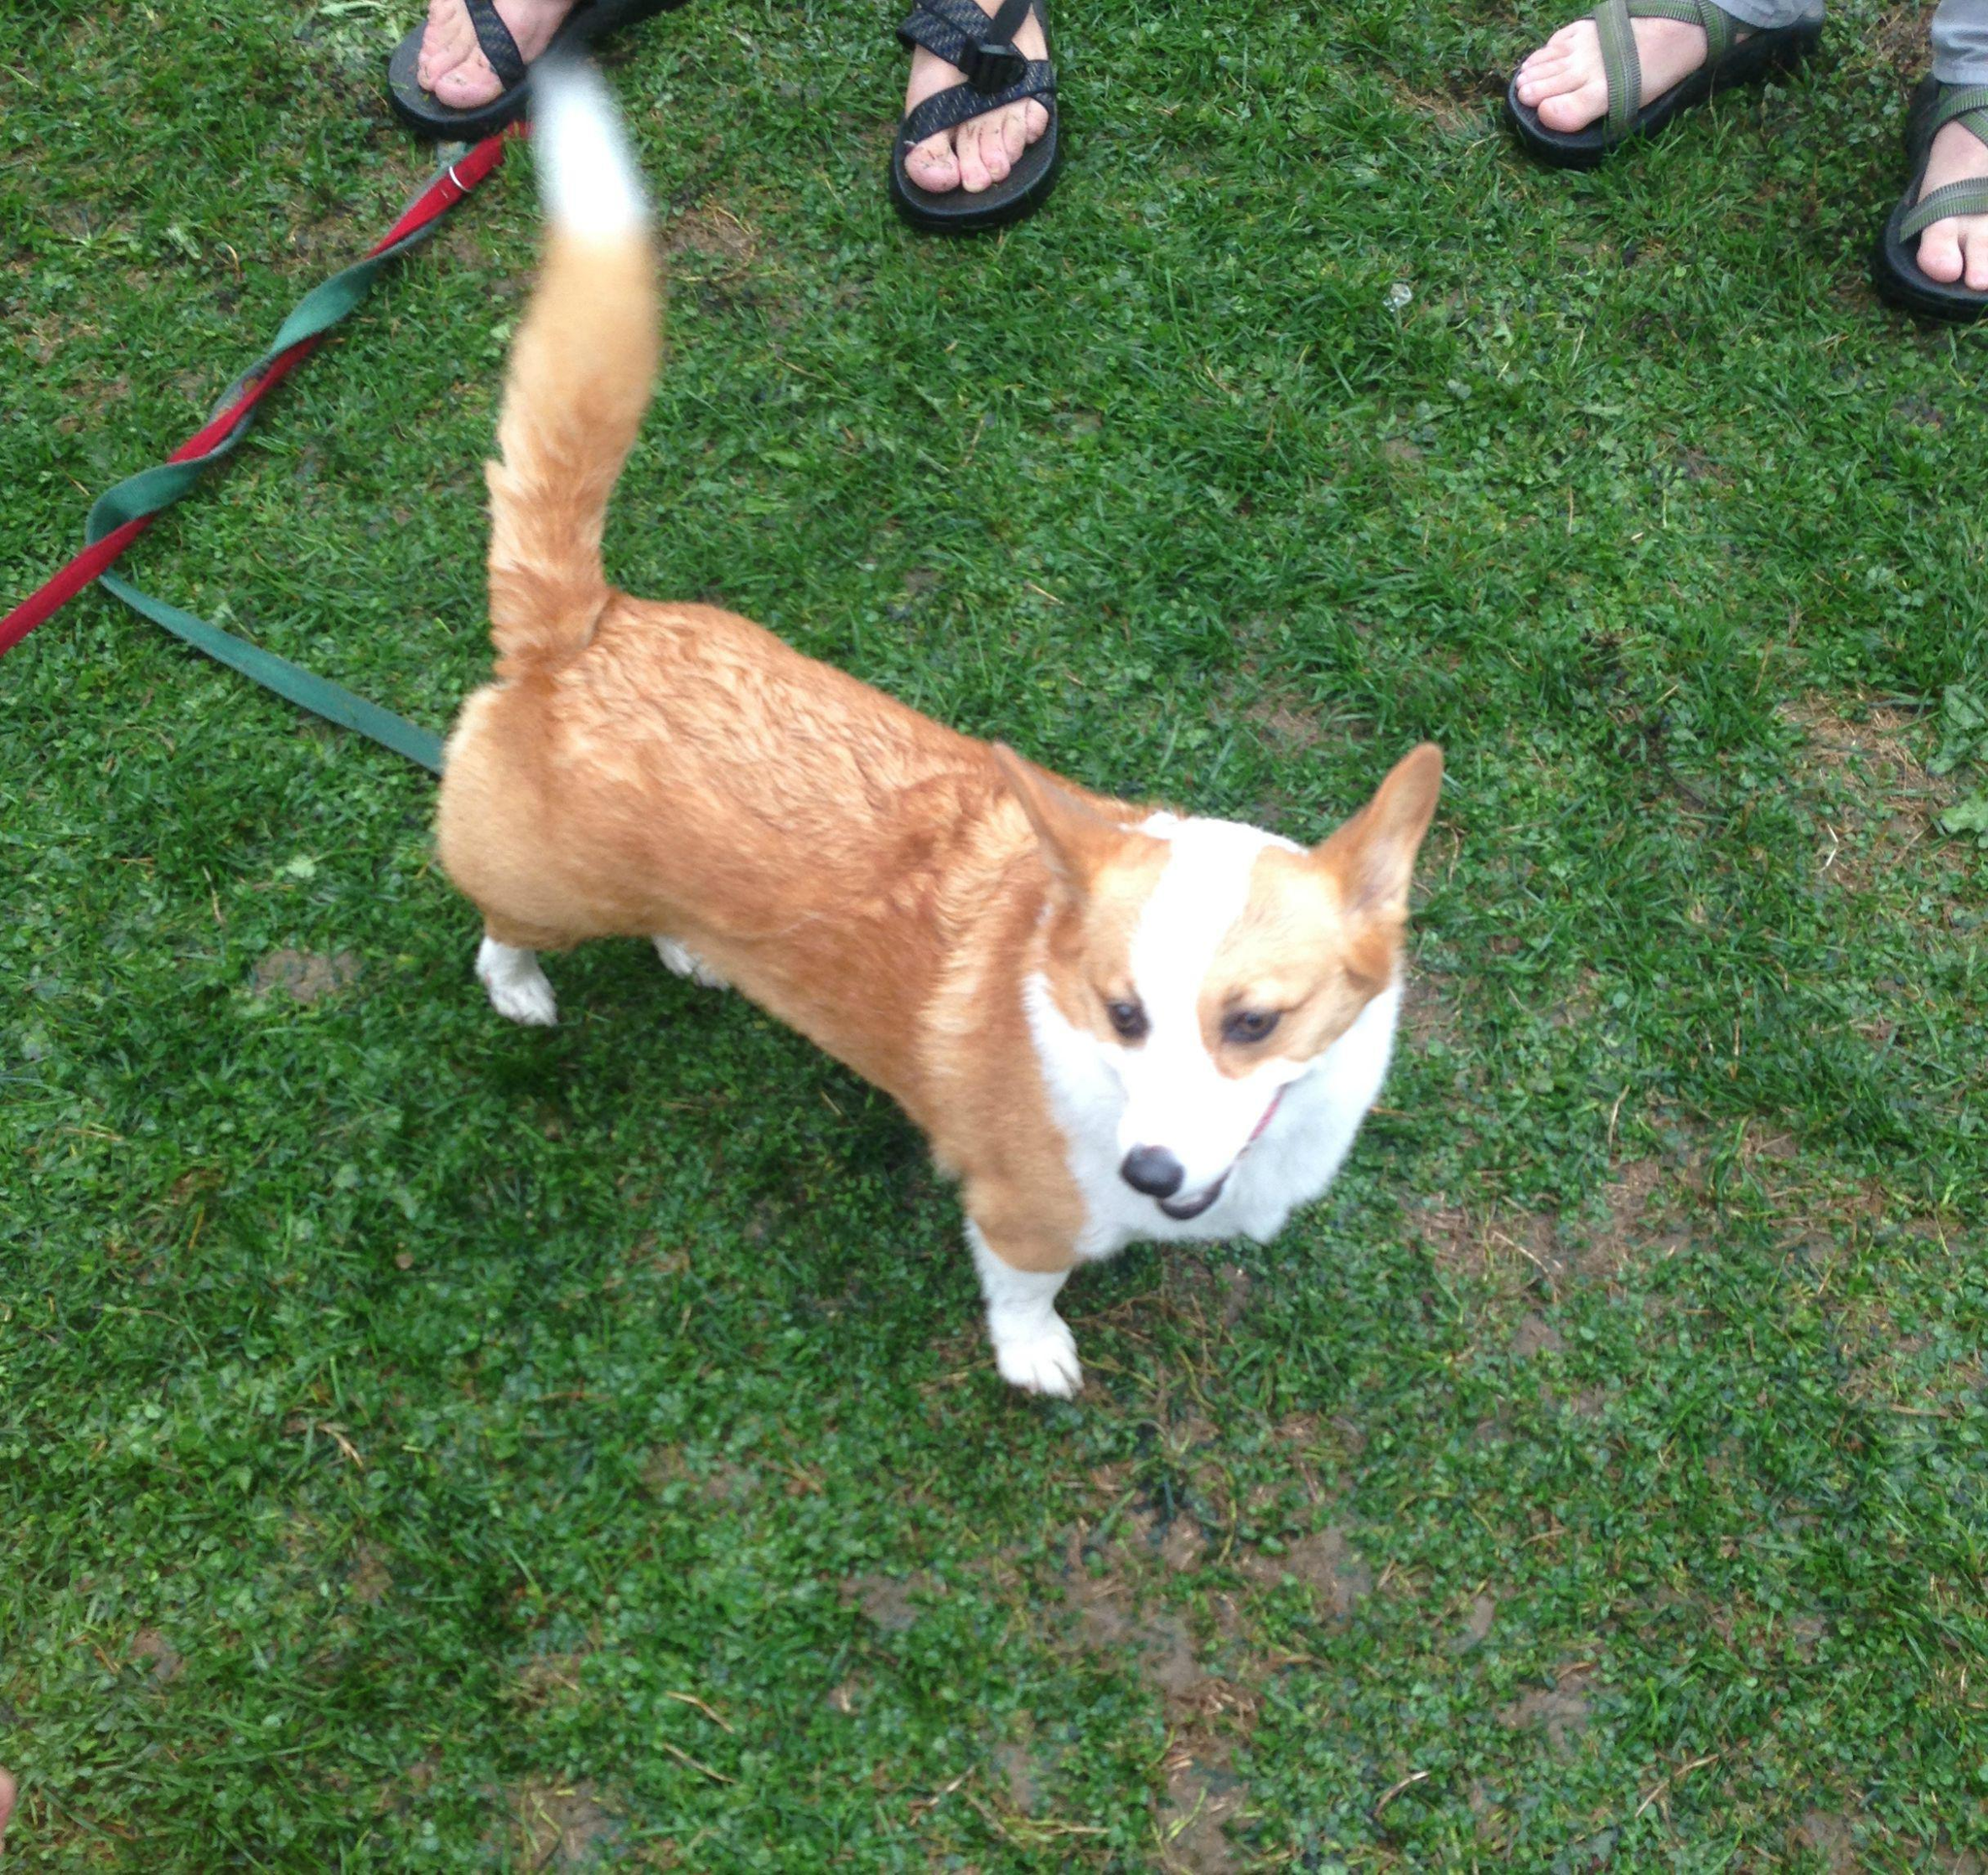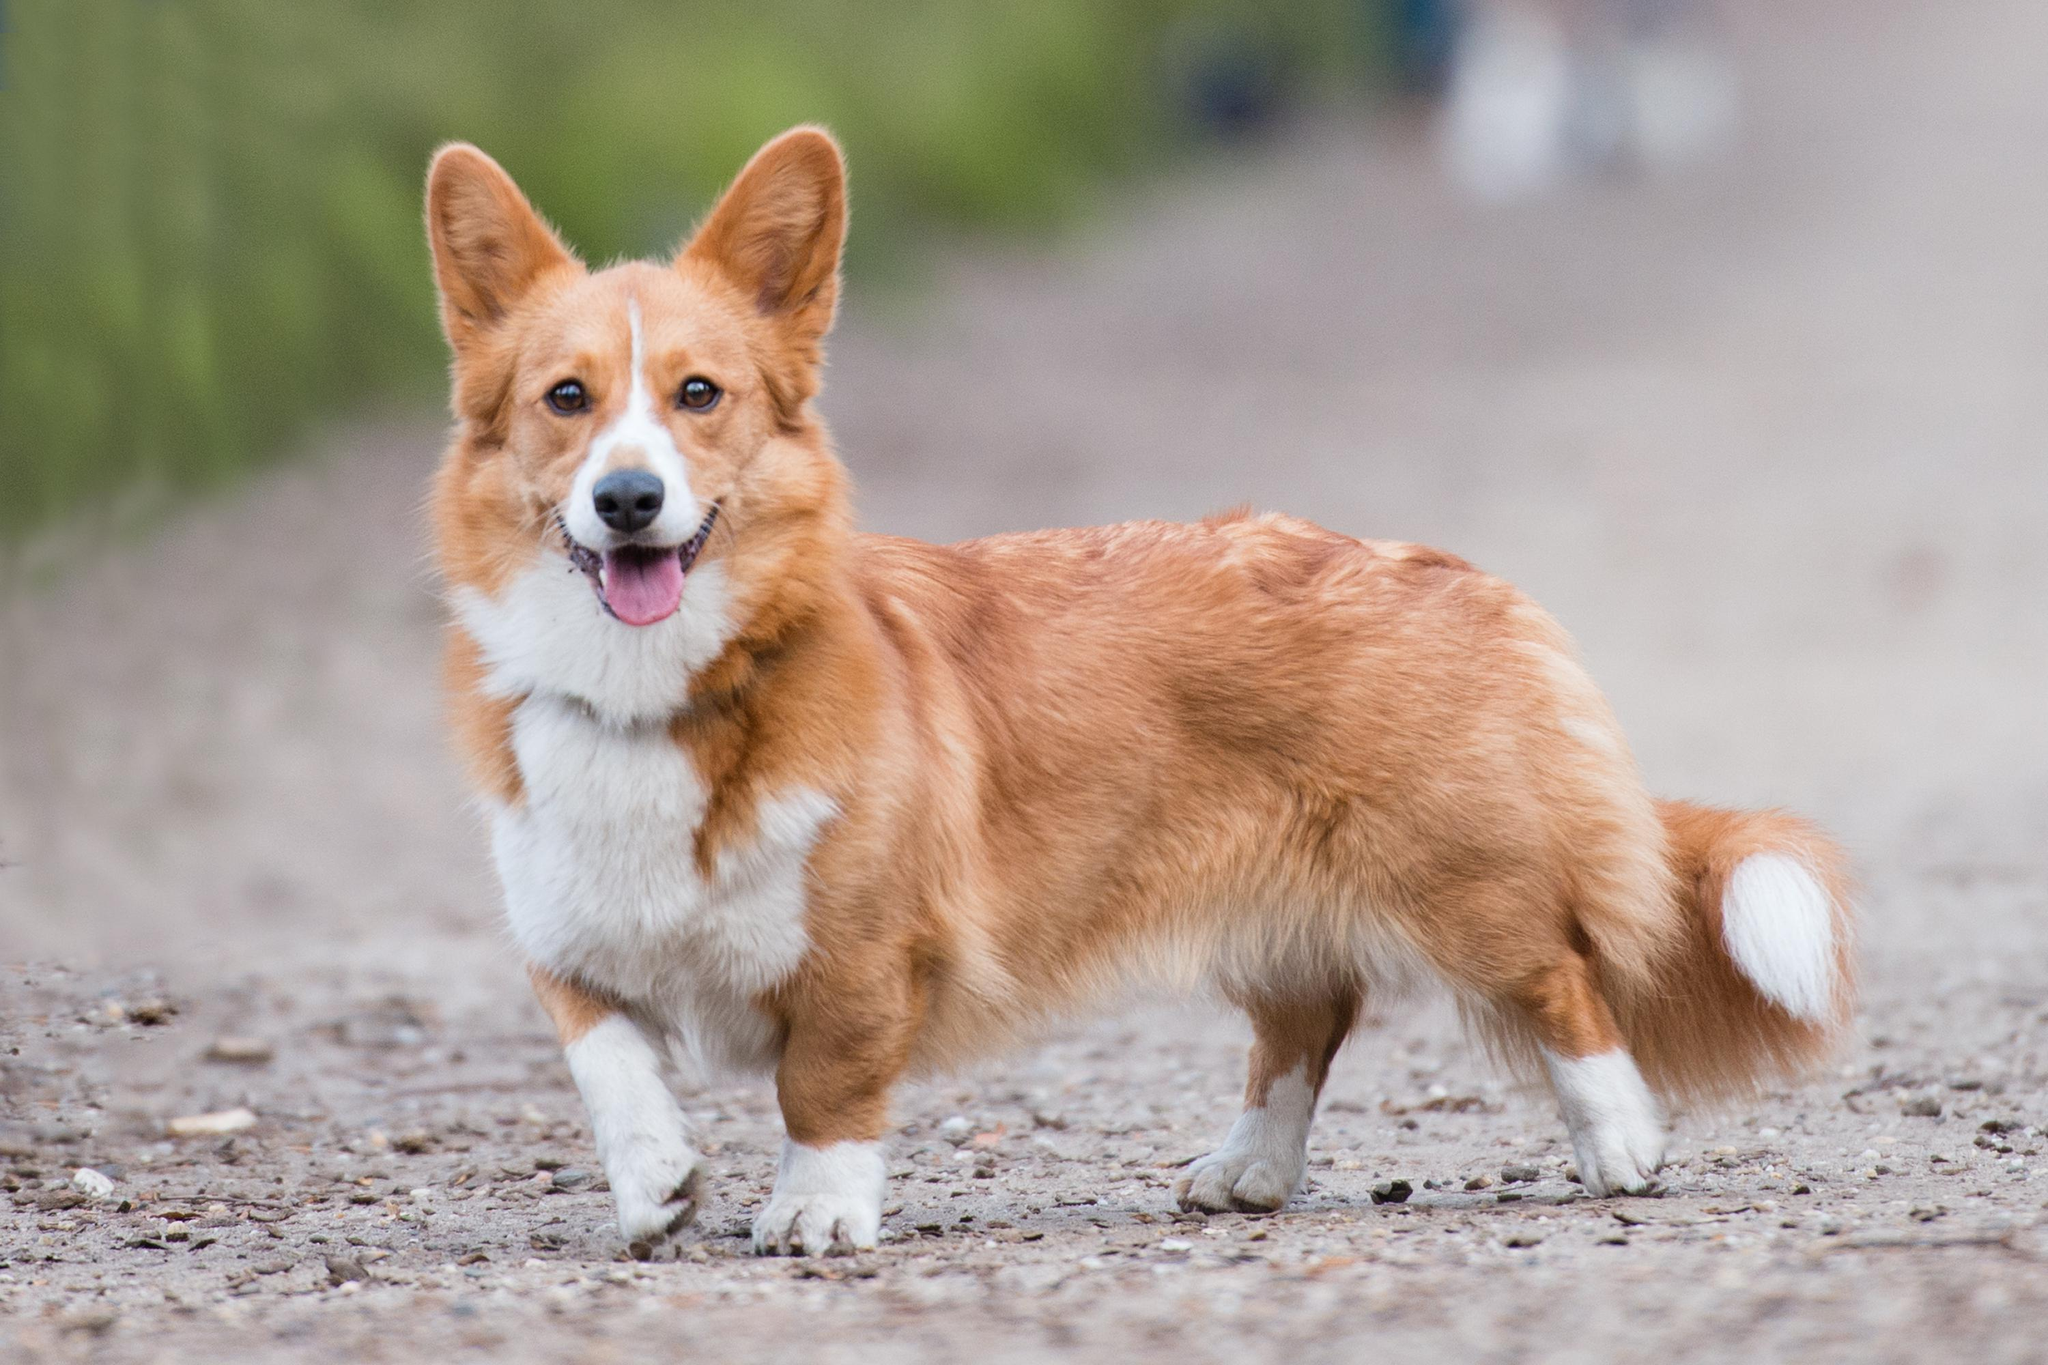The first image is the image on the left, the second image is the image on the right. For the images shown, is this caption "Each image contains exactly one orange-and-white corgi, and at least one of the dogs pictured stands on all fours on green grass." true? Answer yes or no. Yes. The first image is the image on the left, the second image is the image on the right. For the images displayed, is the sentence "The dog in the image on the left is standing in the grass." factually correct? Answer yes or no. Yes. 